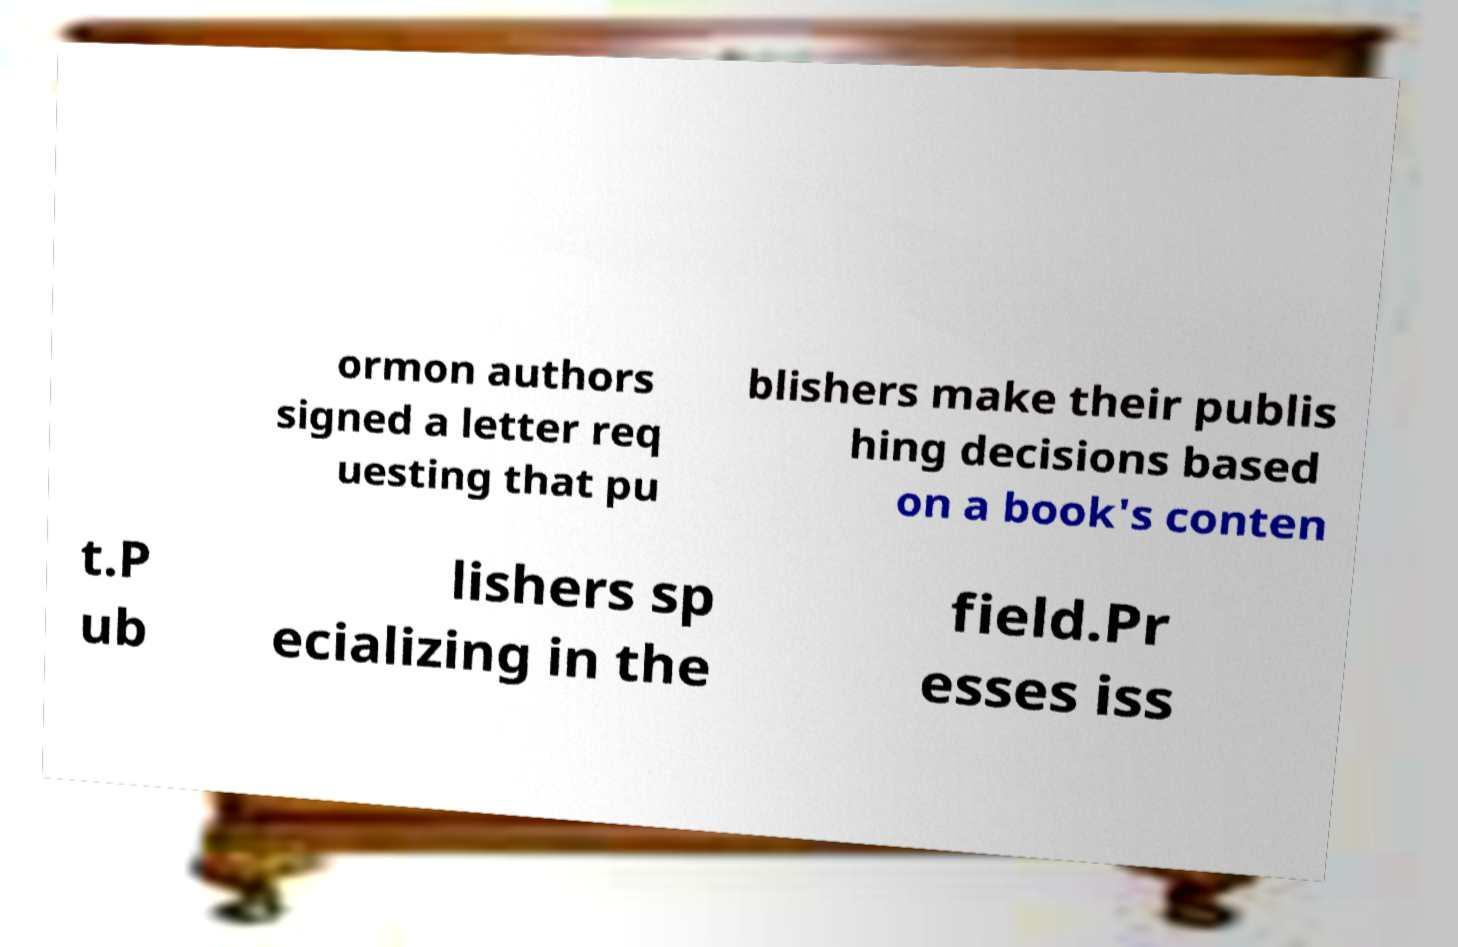Can you read and provide the text displayed in the image?This photo seems to have some interesting text. Can you extract and type it out for me? ormon authors signed a letter req uesting that pu blishers make their publis hing decisions based on a book's conten t.P ub lishers sp ecializing in the field.Pr esses iss 